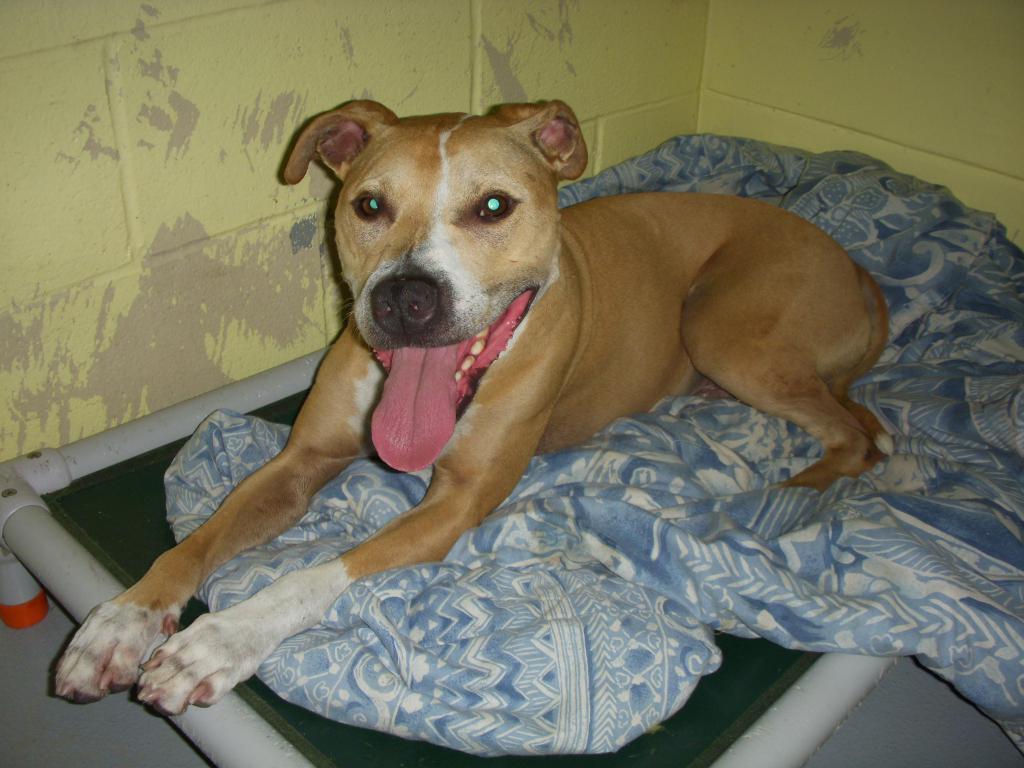Please provide a concise description of this image. In this image we can see the dog on the blanket which is on the bed. We can also see the floor and also the wall. 